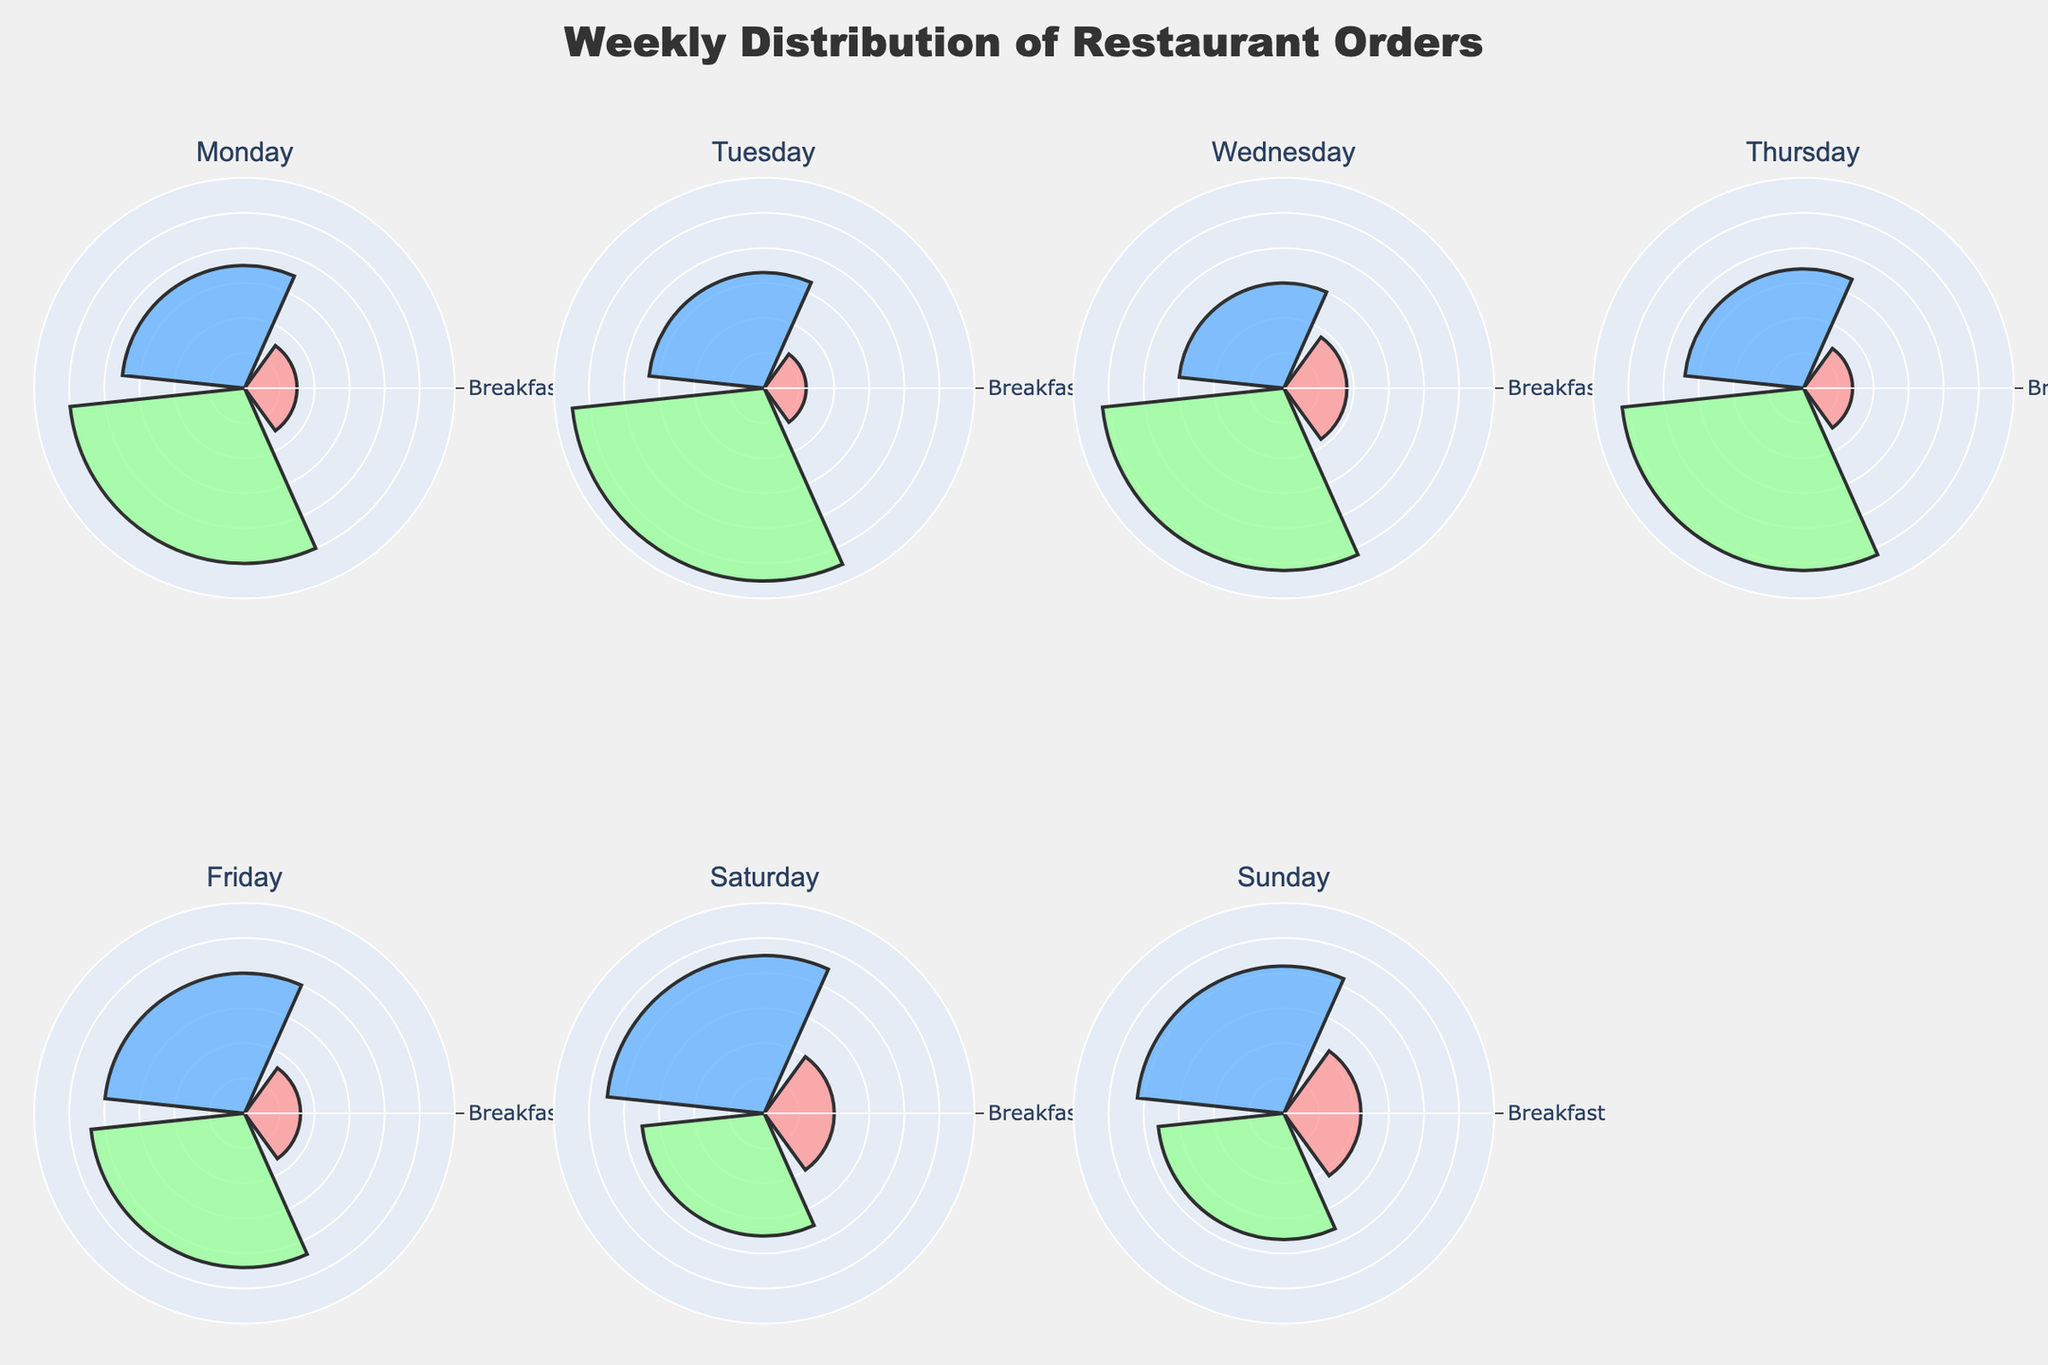What is the title of the figure? The title of the figure is usually placed prominently at the top, indicating the subject. This figure's title is "Weekly Distribution of Restaurant Orders" as formatted in the code.
Answer: Weekly Distribution of Restaurant Orders Which day has the highest percentage of dinner orders? By looking at the segment marked “Dinner” across the different days, the tallest segment among them indicates the highest percentage. Tuesday has the highest percentage at 55%.
Answer: Tuesday What is the percentage distribution of orders on Friday for lunch and dinner combined? First, locate the segments for Friday representing Lunch and Dinner. The percentages for Lunch and Dinner are 40% and 44%, respectively. Adding them together gives 40 + 44 = 84%.
Answer: 84% Which day shows the highest percentage of breakfast orders? By examining the segments that represent breakfast orders on each day, Sunday shows the highest percentage at 22%.
Answer: Sunday Compare the breakfast orders on Monday and Wednesday. Which day has a higher percentage, and by how much? Locate the breakfast segments for Monday and Wednesday. Monday has 15% while Wednesday has 18%. Subtract the two percentages to find the difference, which is 18 - 15 = 3%.
Answer: Wednesday, by 3% On which day is the proportion of lunch orders the greatest? Look at the “Lunch” segments across all days and identify the tallest one. Saturday has the highest lunch order proportion at 45%.
Answer: Saturday How does the distribution of dinner orders on Saturday compare to that on Sunday? Find the dinner order segments for Saturday and Sunday. Saturday has 35% and Sunday has 36%. Sunday’s percentage is slightly higher by 1%.
Answer: Sunday has 1% more Which day has the lowest percentage of breakfast orders, and what is that percentage? Check all the breakfast segments and identify the shortest one. Tuesday has the lowest breakfast order percentage at 12%.
Answer: Tuesday What is the combined percentage of breakfast orders for Monday and Tuesday? Add the breakfast percentages for Monday (15%) and Tuesday (12%). This gives 15 + 12 = 27%.
Answer: 27% Which day has a larger difference between lunch and dinner orders, Thursday or Friday? Calculate the differences for both days. Thursday's Lunch (34%) and Dinner (52%) difference = 52 - 34 = 18%. Friday's Lunch (40%) and Dinner (44%) difference = 44 - 40 = 4%. Thursday has a larger difference.
Answer: Thursday, by 14% 